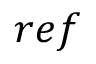Convert formula to latex. <formula><loc_0><loc_0><loc_500><loc_500>r e f</formula> 